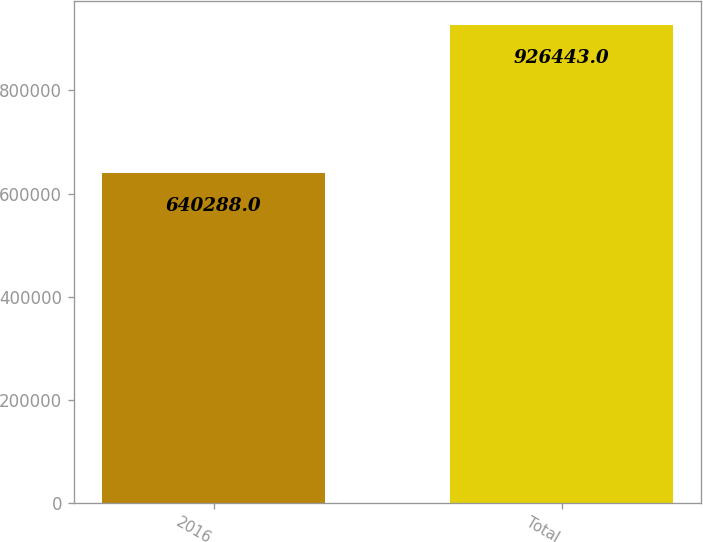Convert chart. <chart><loc_0><loc_0><loc_500><loc_500><bar_chart><fcel>2016<fcel>Total<nl><fcel>640288<fcel>926443<nl></chart> 